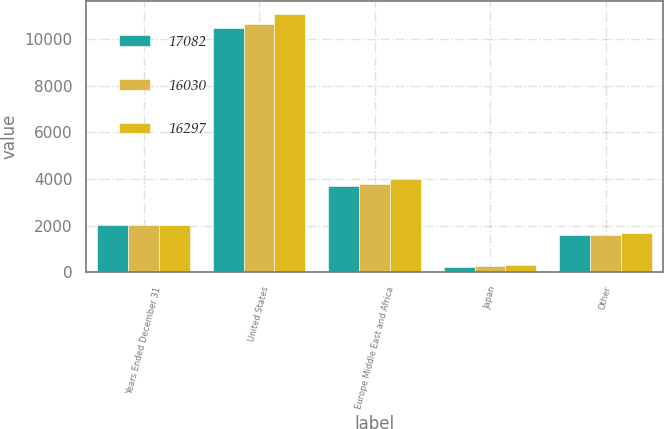Convert chart to OTSL. <chart><loc_0><loc_0><loc_500><loc_500><stacked_bar_chart><ecel><fcel>Years Ended December 31<fcel>United States<fcel>Europe Middle East and Africa<fcel>Japan<fcel>Other<nl><fcel>17082<fcel>2012<fcel>10490<fcel>3688<fcel>243<fcel>1609<nl><fcel>16030<fcel>2011<fcel>10646<fcel>3780<fcel>279<fcel>1592<nl><fcel>16297<fcel>2010<fcel>11078<fcel>4014<fcel>315<fcel>1675<nl></chart> 